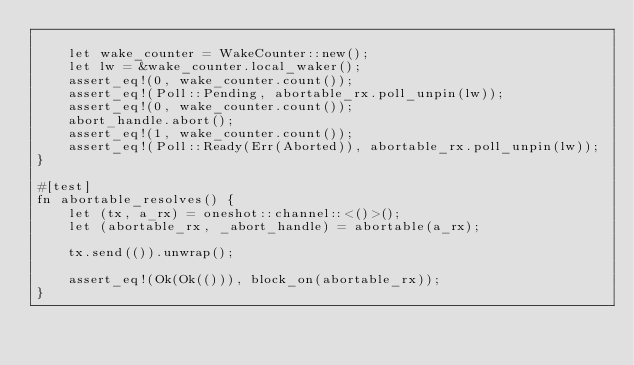Convert code to text. <code><loc_0><loc_0><loc_500><loc_500><_Rust_>
    let wake_counter = WakeCounter::new();
    let lw = &wake_counter.local_waker();
    assert_eq!(0, wake_counter.count());
    assert_eq!(Poll::Pending, abortable_rx.poll_unpin(lw));
    assert_eq!(0, wake_counter.count());
    abort_handle.abort();
    assert_eq!(1, wake_counter.count());
    assert_eq!(Poll::Ready(Err(Aborted)), abortable_rx.poll_unpin(lw));
}

#[test]
fn abortable_resolves() {
    let (tx, a_rx) = oneshot::channel::<()>();
    let (abortable_rx, _abort_handle) = abortable(a_rx);

    tx.send(()).unwrap();

    assert_eq!(Ok(Ok(())), block_on(abortable_rx));
}
</code> 